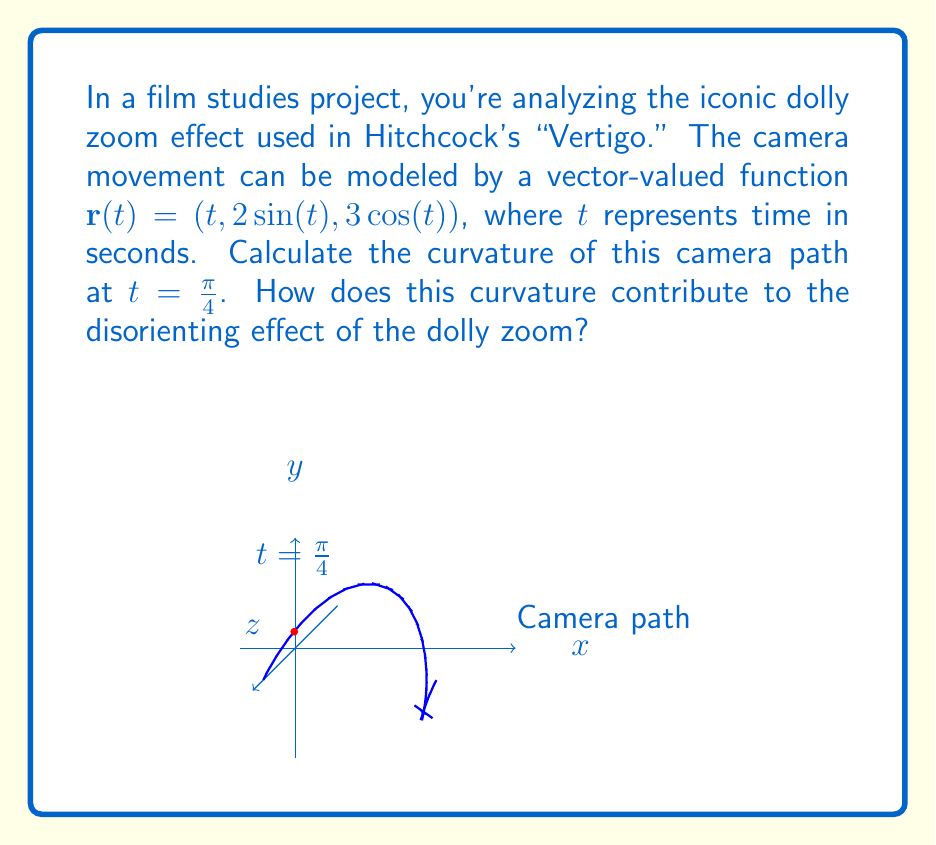Provide a solution to this math problem. Let's approach this step-by-step:

1) The curvature $\kappa$ of a vector-valued function $\mathbf{r}(t)$ is given by:

   $$\kappa = \frac{|\mathbf{r}'(t) \times \mathbf{r}''(t)|}{|\mathbf{r}'(t)|^3}$$

2) We need to find $\mathbf{r}'(t)$ and $\mathbf{r}''(t)$:

   $\mathbf{r}'(t) = (1, 2\cos(t), -3\sin(t))$
   $\mathbf{r}''(t) = (0, -2\sin(t), -3\cos(t))$

3) At $t = \frac{\pi}{4}$:

   $\mathbf{r}'(\frac{\pi}{4}) = (1, 2\cos(\frac{\pi}{4}), -3\sin(\frac{\pi}{4})) = (1, \sqrt{2}, -\frac{3\sqrt{2}}{2})$
   $\mathbf{r}''(\frac{\pi}{4}) = (0, -2\sin(\frac{\pi}{4}), -3\cos(\frac{\pi}{4})) = (0, -\sqrt{2}, -\frac{3\sqrt{2}}{2})$

4) Calculate the cross product $\mathbf{r}'(\frac{\pi}{4}) \times \mathbf{r}''(\frac{\pi}{4})$:

   $$\begin{vmatrix} 
   \mathbf{i} & \mathbf{j} & \mathbf{k} \\
   1 & \sqrt{2} & -\frac{3\sqrt{2}}{2} \\
   0 & -\sqrt{2} & -\frac{3\sqrt{2}}{2}
   \end{vmatrix} = (-\frac{3\sqrt{2}}{2} + \frac{3\sqrt{2}}{2})\mathbf{i} + (0 + 0)\mathbf{j} + (\sqrt{2} + \sqrt{2})\mathbf{k} = 2\sqrt{2}\mathbf{k}$$

5) Calculate $|\mathbf{r}'(\frac{\pi}{4}) \times \mathbf{r}''(\frac{\pi}{4})|$:

   $|2\sqrt{2}\mathbf{k}| = 2\sqrt{2}$

6) Calculate $|\mathbf{r}'(\frac{\pi}{4})|^3$:

   $|\mathbf{r}'(\frac{\pi}{4})|^3 = (1^2 + 2^2 + (\frac{3\sqrt{2}}{2})^2)^{3/2} = (\frac{13}{2})^{3/2}$

7) Therefore, the curvature at $t = \frac{\pi}{4}$ is:

   $$\kappa = \frac{2\sqrt{2}}{(\frac{13}{2})^{3/2}} = \frac{4\sqrt{2}}{13\sqrt{13}}$$

This high curvature contributes to the disorienting effect of the dolly zoom by creating a rapid change in perspective. As the camera moves along this curved path while zooming, it creates a visual distortion that mimics the feeling of vertigo, enhancing the psychological impact of the scene.
Answer: $\kappa = \frac{4\sqrt{2}}{13\sqrt{13}}$ 